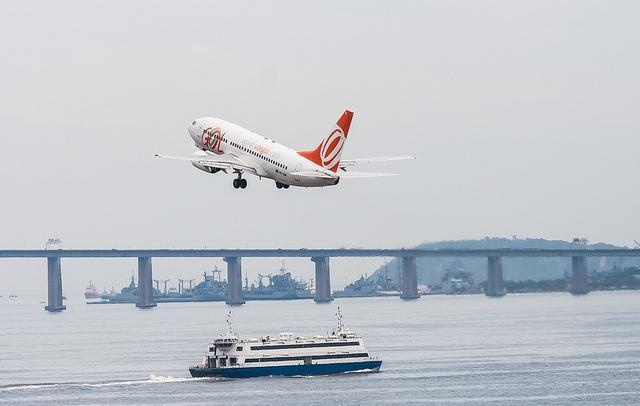How many boats can you see?
Give a very brief answer. 1. How many airplanes can be seen?
Give a very brief answer. 1. How many people appear in the picture?
Give a very brief answer. 0. 